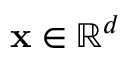<formula> <loc_0><loc_0><loc_500><loc_500>x \in \mathbb { R } ^ { d }</formula> 